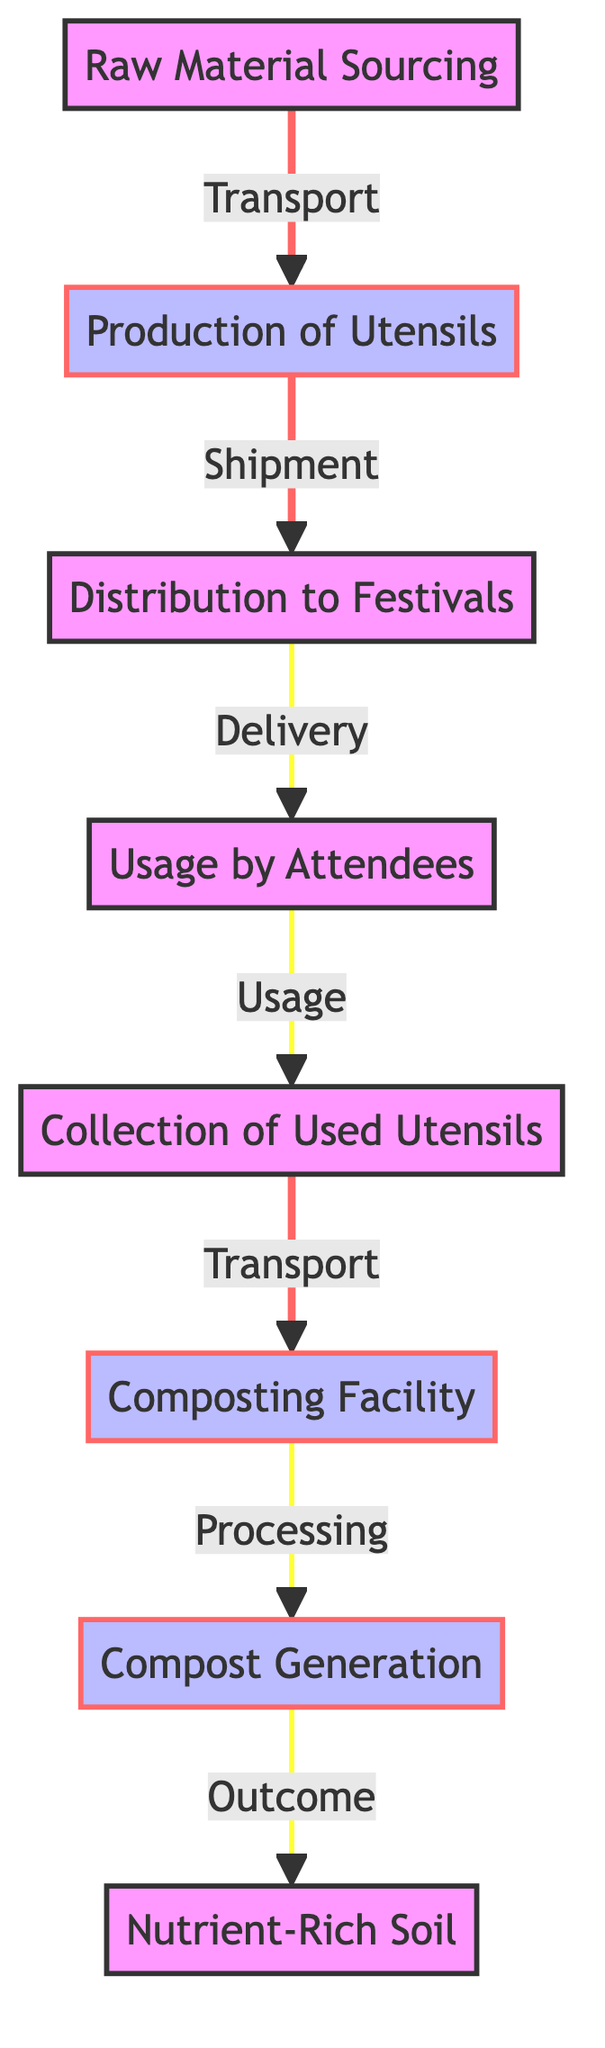What is the first step in the process? The first step in the process is "Raw Material Sourcing," as it is the initial node in the diagram that leads to the production of utensils.
Answer: Raw Material Sourcing How many primary processes are involved in the lifecycle? There are three primary processes identified in the lifecycle: Production of Utensils, Composting Facility, and Compost Generation.
Answer: 3 What type of connection exists between 'Collection of Used Utensils' and 'Composting Facility'? The connection between 'Collection of Used Utensils' and 'Composting Facility' is defined as "Transport," which indicates the movement of collected utensils to the composting location.
Answer: Transport How is 'Compost Generation' related to 'Nutrient-Rich Soil'? 'Compost Generation' leads to 'Nutrient-Rich Soil' through the process defined as "Outcome," indicating that the result of composting is nutrient-rich soil, a product of the earlier process.
Answer: Outcome What is the last stage in the lifecycle of biodegradable festival utensils? The last stage in the lifecycle is 'Nutrient-Rich Soil,' which is the final outcome after composting the utensils.
Answer: Nutrient-Rich Soil How many nodes does the diagram have? The diagram contains eight nodes that represent different stages and points in the lifecycle of biodegradable festival utensils.
Answer: 8 What happens to the utensils after they are used by attendees? After usage, the utensils are collected in a process indicated in the diagram, leading to the next steps of transport to the compost facility.
Answer: Collection of Used Utensils What is transported after the 'Production of Utensils'? After the 'Production of Utensils,' the items that are transported are delivered to festivals, marking the distribution phase of the lifecycle.
Answer: Distribution to Festivals What is the relationship between 'Distribution to Festivals' and 'Usage by Attendees'? The relationship is established as "Delivery," showing that the utensils are delivered to attendees to be used during the festival.
Answer: Delivery 